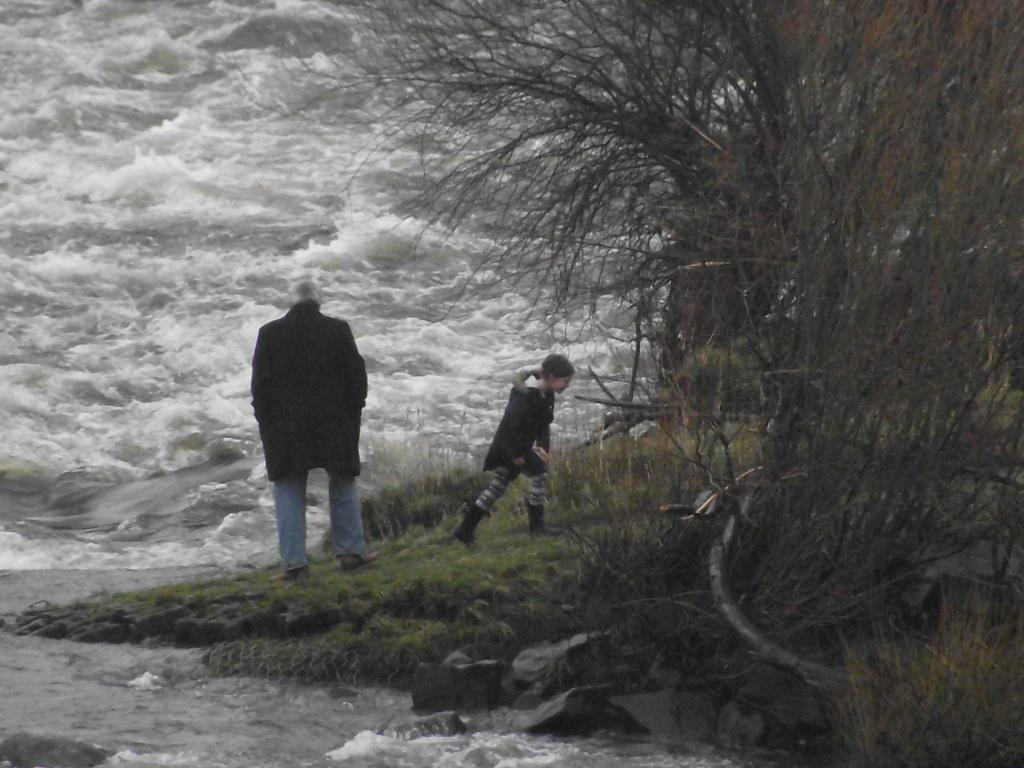What is the man doing in the image? The man is standing on the ground in the image. What is the kid doing in the image? The kid is walking on the ground in the image. What can be seen in the background of the image? Water, stones, and trees are visible in the background of the image. What type of crate is being carried by the hands in the image? There is no crate or hands present in the image. 